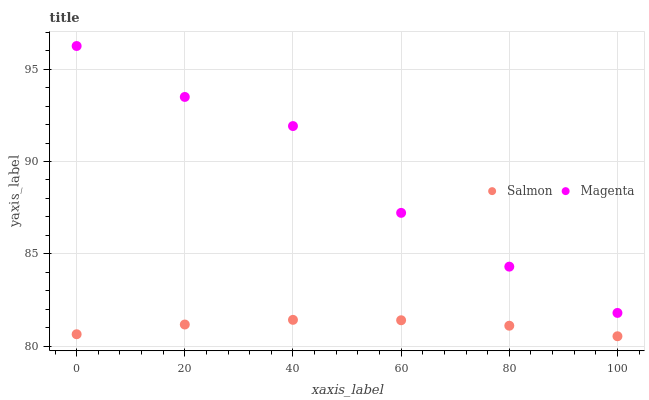Does Salmon have the minimum area under the curve?
Answer yes or no. Yes. Does Magenta have the maximum area under the curve?
Answer yes or no. Yes. Does Salmon have the maximum area under the curve?
Answer yes or no. No. Is Salmon the smoothest?
Answer yes or no. Yes. Is Magenta the roughest?
Answer yes or no. Yes. Is Salmon the roughest?
Answer yes or no. No. Does Salmon have the lowest value?
Answer yes or no. Yes. Does Magenta have the highest value?
Answer yes or no. Yes. Does Salmon have the highest value?
Answer yes or no. No. Is Salmon less than Magenta?
Answer yes or no. Yes. Is Magenta greater than Salmon?
Answer yes or no. Yes. Does Salmon intersect Magenta?
Answer yes or no. No. 